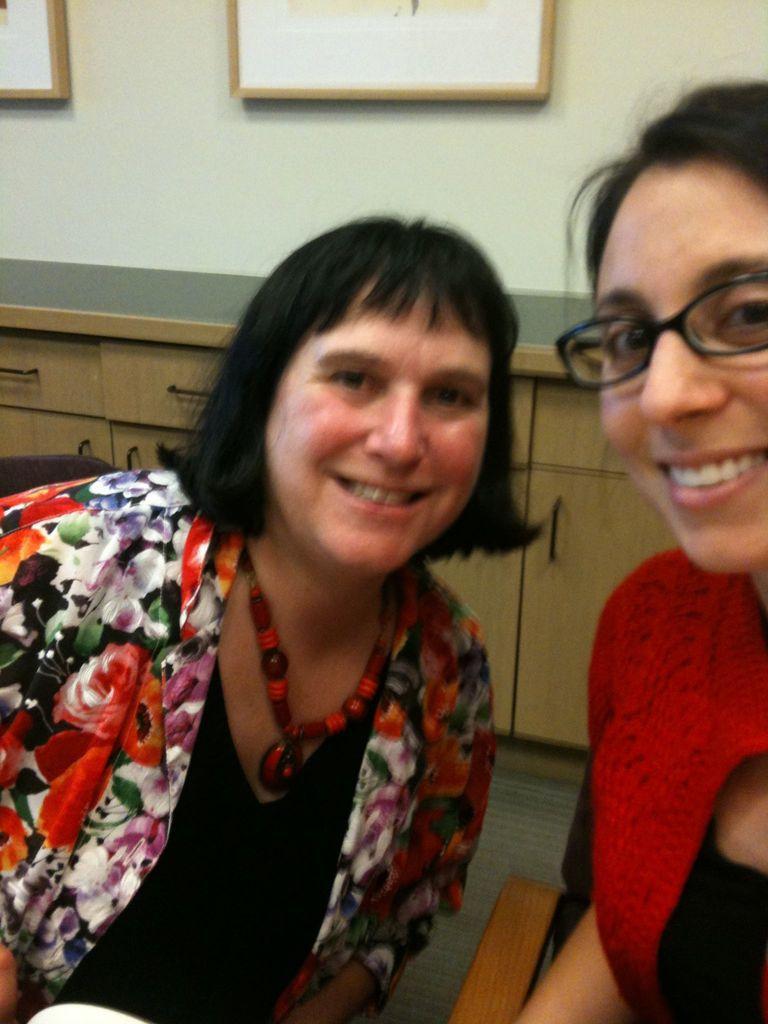In one or two sentences, can you explain what this image depicts? In this image, we can see two persons wearing clothes in front of the cupboard. The person who is on the right side of the image wearing spectacles. There is a photo frame at the top of the image. 